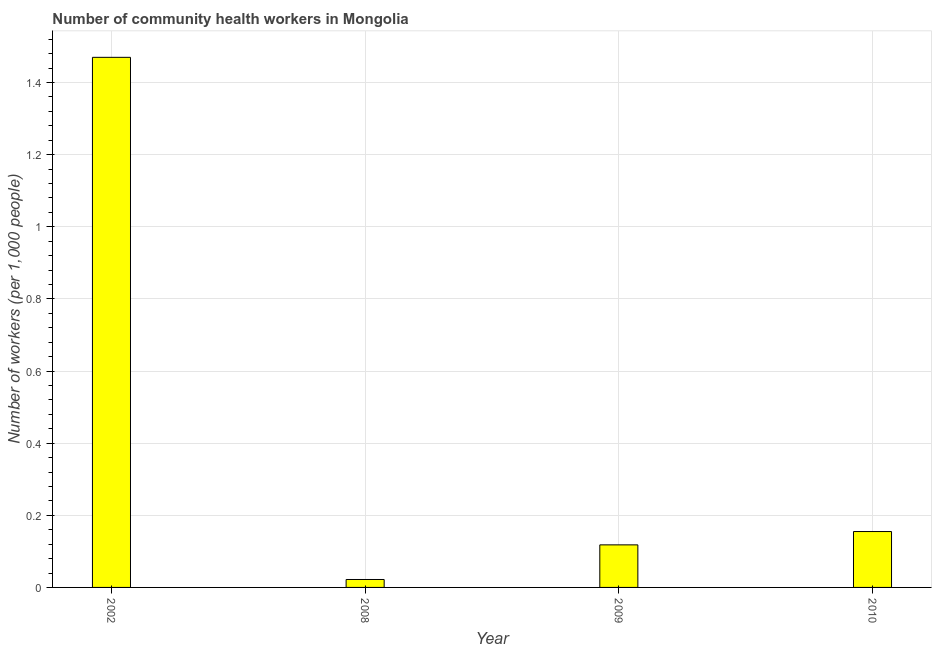Does the graph contain grids?
Give a very brief answer. Yes. What is the title of the graph?
Provide a short and direct response. Number of community health workers in Mongolia. What is the label or title of the X-axis?
Your answer should be compact. Year. What is the label or title of the Y-axis?
Your response must be concise. Number of workers (per 1,0 people). What is the number of community health workers in 2008?
Your answer should be compact. 0.02. Across all years, what is the maximum number of community health workers?
Ensure brevity in your answer.  1.47. Across all years, what is the minimum number of community health workers?
Keep it short and to the point. 0.02. In which year was the number of community health workers maximum?
Offer a terse response. 2002. What is the sum of the number of community health workers?
Provide a short and direct response. 1.76. What is the difference between the number of community health workers in 2009 and 2010?
Your response must be concise. -0.04. What is the average number of community health workers per year?
Make the answer very short. 0.44. What is the median number of community health workers?
Provide a succinct answer. 0.14. In how many years, is the number of community health workers greater than 0.12 ?
Keep it short and to the point. 2. What is the ratio of the number of community health workers in 2002 to that in 2009?
Ensure brevity in your answer.  12.46. What is the difference between the highest and the second highest number of community health workers?
Make the answer very short. 1.31. Is the sum of the number of community health workers in 2002 and 2009 greater than the maximum number of community health workers across all years?
Offer a terse response. Yes. What is the difference between the highest and the lowest number of community health workers?
Offer a very short reply. 1.45. In how many years, is the number of community health workers greater than the average number of community health workers taken over all years?
Your answer should be compact. 1. Are all the bars in the graph horizontal?
Keep it short and to the point. No. What is the difference between two consecutive major ticks on the Y-axis?
Your answer should be very brief. 0.2. What is the Number of workers (per 1,000 people) of 2002?
Your answer should be compact. 1.47. What is the Number of workers (per 1,000 people) of 2008?
Ensure brevity in your answer.  0.02. What is the Number of workers (per 1,000 people) in 2009?
Give a very brief answer. 0.12. What is the Number of workers (per 1,000 people) of 2010?
Keep it short and to the point. 0.15. What is the difference between the Number of workers (per 1,000 people) in 2002 and 2008?
Offer a terse response. 1.45. What is the difference between the Number of workers (per 1,000 people) in 2002 and 2009?
Give a very brief answer. 1.35. What is the difference between the Number of workers (per 1,000 people) in 2002 and 2010?
Your answer should be very brief. 1.31. What is the difference between the Number of workers (per 1,000 people) in 2008 and 2009?
Provide a succinct answer. -0.1. What is the difference between the Number of workers (per 1,000 people) in 2008 and 2010?
Offer a very short reply. -0.13. What is the difference between the Number of workers (per 1,000 people) in 2009 and 2010?
Your answer should be very brief. -0.04. What is the ratio of the Number of workers (per 1,000 people) in 2002 to that in 2008?
Provide a short and direct response. 66.82. What is the ratio of the Number of workers (per 1,000 people) in 2002 to that in 2009?
Give a very brief answer. 12.46. What is the ratio of the Number of workers (per 1,000 people) in 2002 to that in 2010?
Your response must be concise. 9.48. What is the ratio of the Number of workers (per 1,000 people) in 2008 to that in 2009?
Offer a terse response. 0.19. What is the ratio of the Number of workers (per 1,000 people) in 2008 to that in 2010?
Offer a very short reply. 0.14. What is the ratio of the Number of workers (per 1,000 people) in 2009 to that in 2010?
Your answer should be compact. 0.76. 